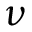Convert formula to latex. <formula><loc_0><loc_0><loc_500><loc_500>\nu</formula> 